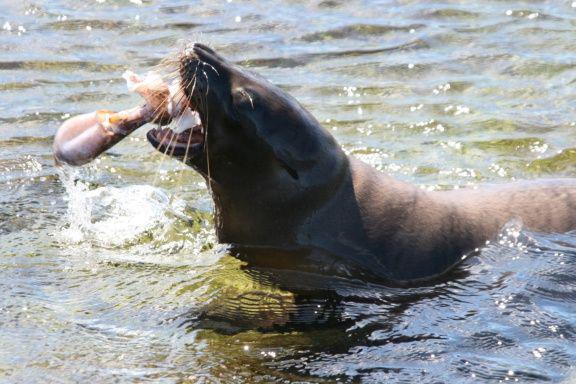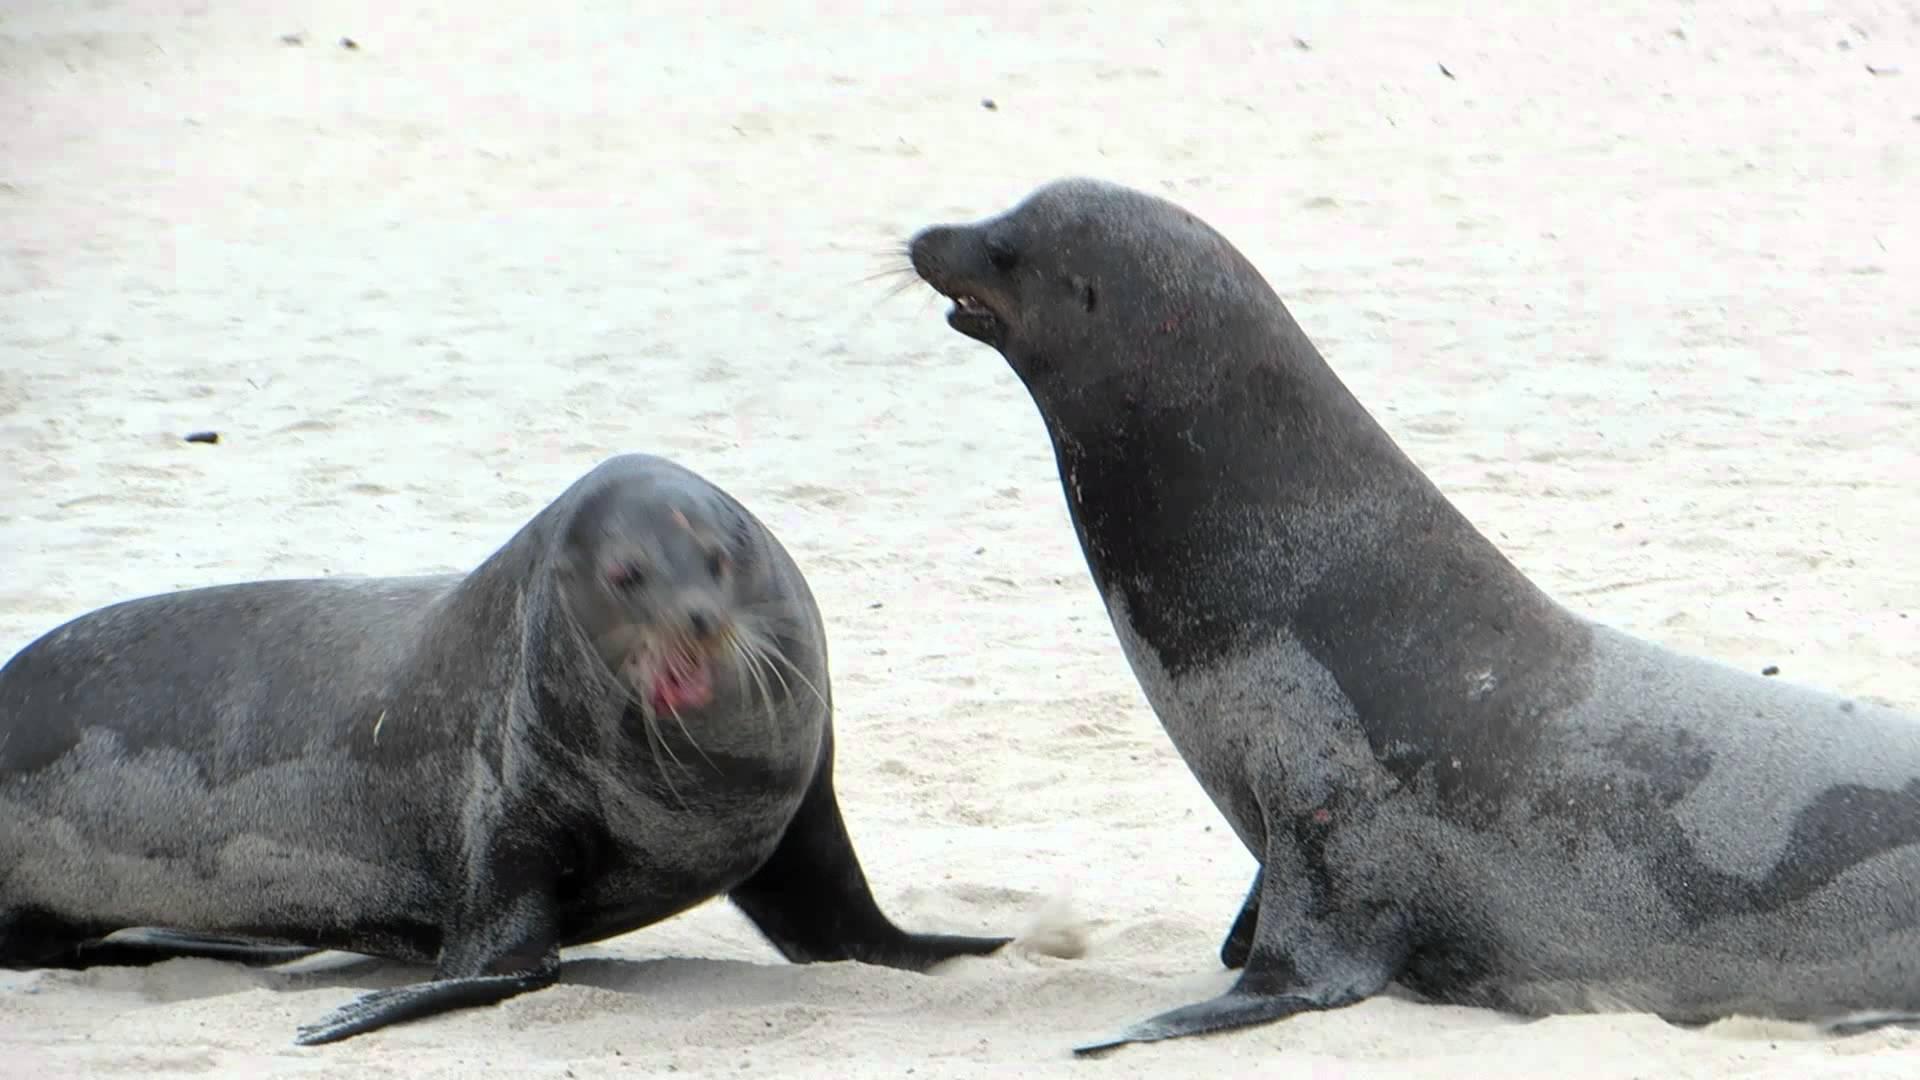The first image is the image on the left, the second image is the image on the right. For the images displayed, is the sentence "A seal is catching a fish." factually correct? Answer yes or no. Yes. The first image is the image on the left, the second image is the image on the right. Assess this claim about the two images: "The right image contains no more than one seal.". Correct or not? Answer yes or no. No. 